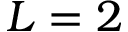<formula> <loc_0><loc_0><loc_500><loc_500>L = 2</formula> 